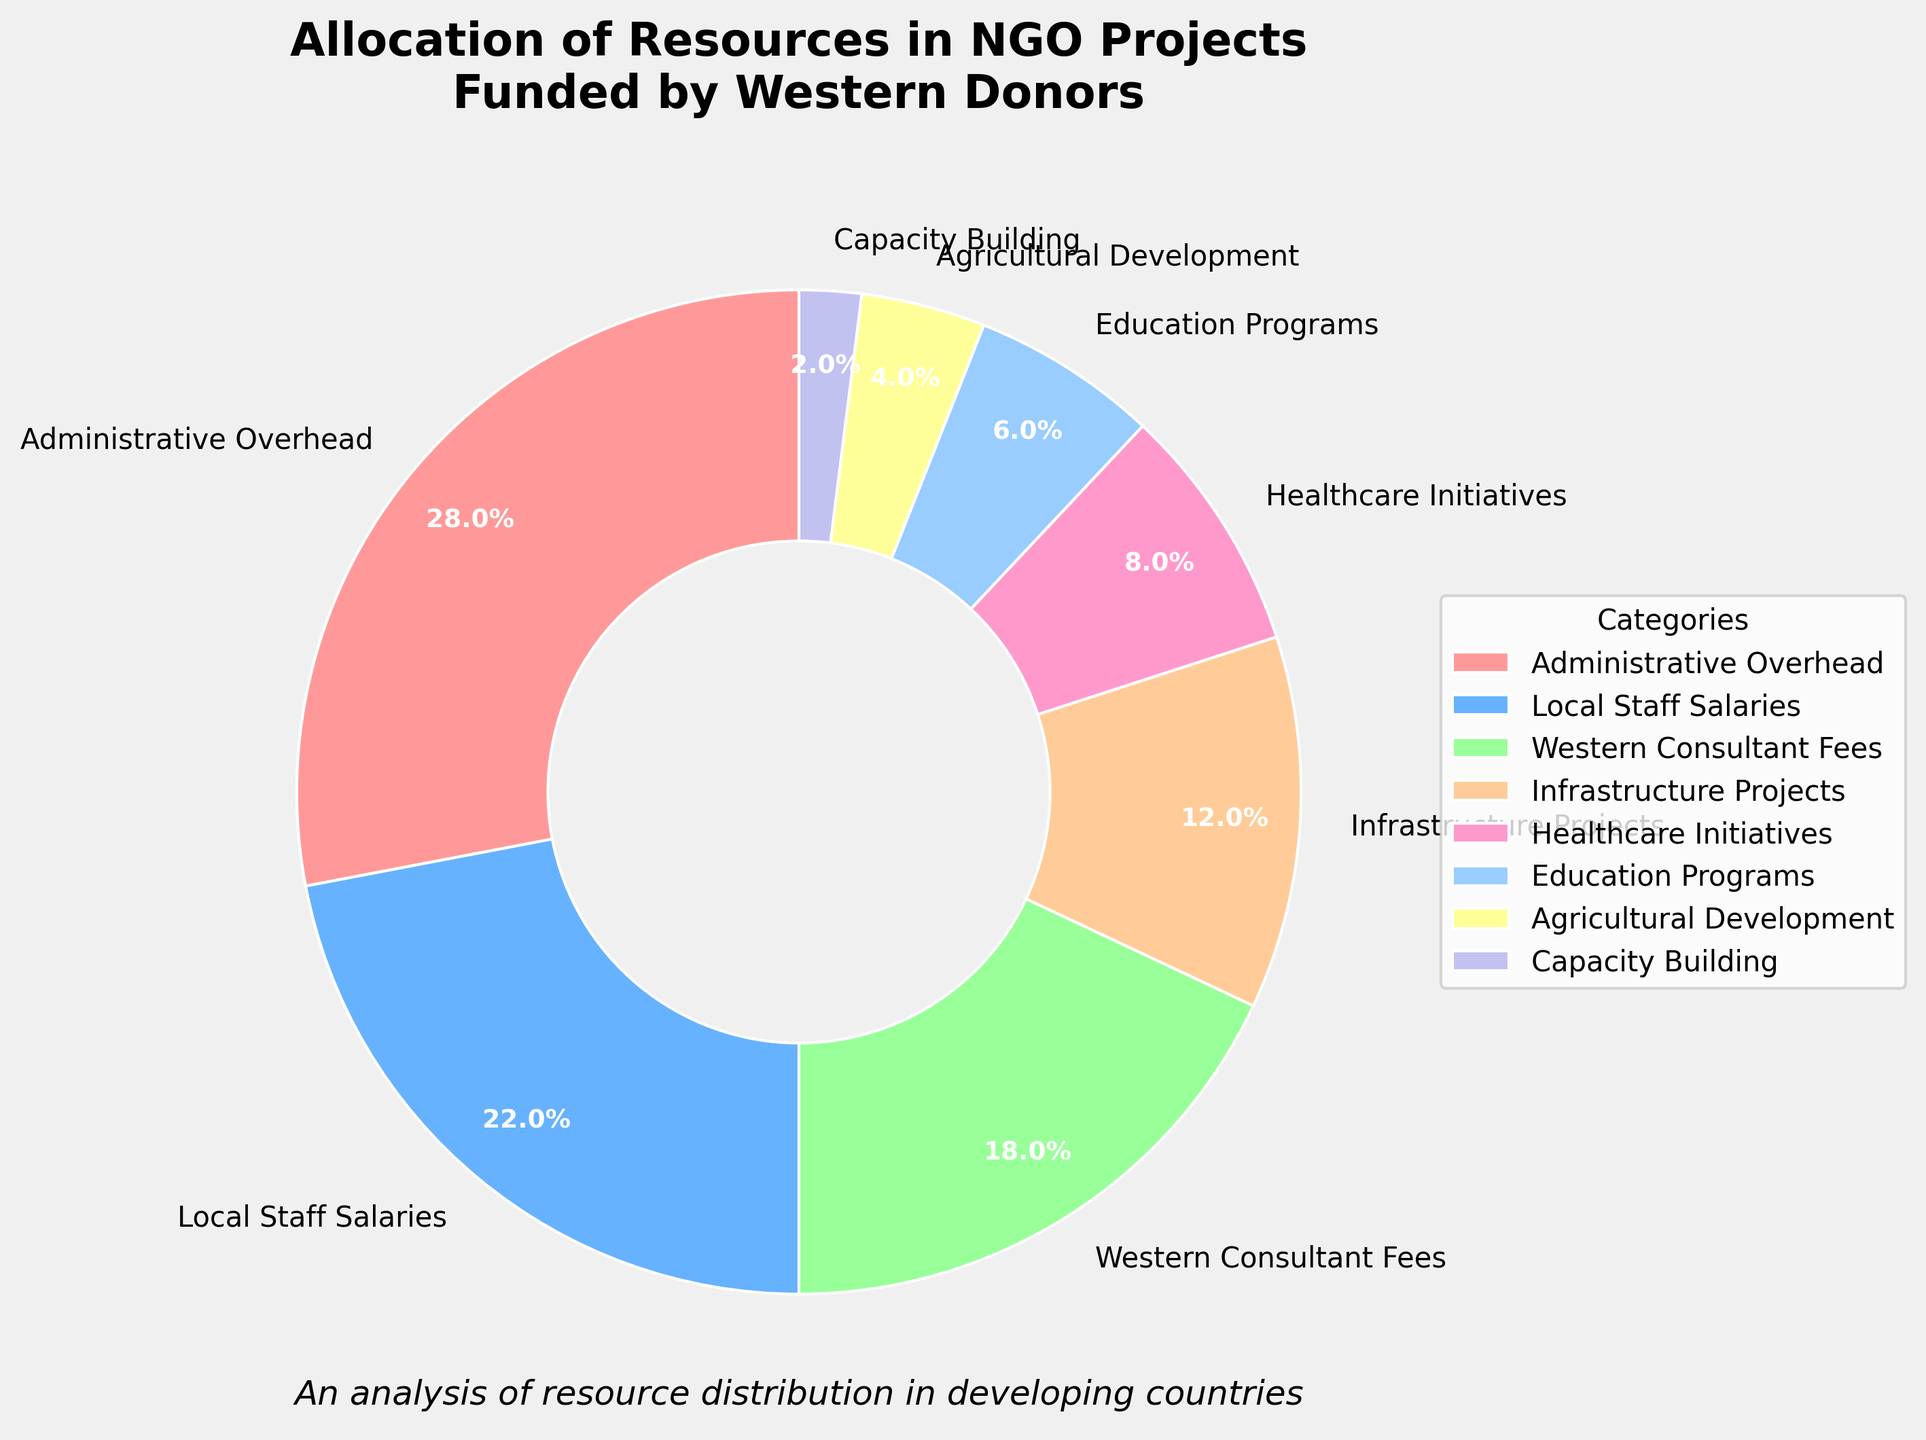What percentage of the resources is allocated to Agricultural Development? Locate the segment labeled "Agricultural Development" in the pie chart and read the corresponding percentage value.
Answer: 4% Sum the percentages of Local Staff Salaries and Western Consultant Fees. Identify the segments labeled "Local Staff Salaries" and "Western Consultant Fees" in the pie chart, add their percentages (22% + 18%).
Answer: 40% Which category receives fewer resources: Infrastructure Projects or Healthcare Initiatives? Compare the percentages of the segments labeled "Infrastructure Projects" (12%) and "Healthcare Initiatives" (8%) in the pie chart.
Answer: Healthcare Initiatives What is the color of the segment representing Education Programs? Locate the segment labeled "Education Programs" in the pie chart and observe its color.
Answer: Light Blue Calculate the difference in percentage between Administrative Overhead and Local Staff Salaries. Subtract the percentage of Local Staff Salaries (22%) from the percentage of Administrative Overhead (28%) by finding the respective segments in the pie chart.
Answer: 6% If the total funding is $100,000, how much is allocated to Infrastructure Projects in dollar amount? Convert the percentage of Infrastructure Projects (12%) to a dollar amount by taking 12% of $100,000, which is (12/100) * $100,000.
Answer: $12,000 Which category has the smallest allocation of resources? Identify the segment with the smallest percentage value in the pie chart.
Answer: Capacity Building What is the total percentage allocated to Education Programs, Healthcare Initiatives, and Agricultural Development combined? Locate the segments for Education Programs (6%), Healthcare Initiatives (8%), and Agricultural Development (4%) in the pie chart, then add their percentages (6% + 8% + 4%).
Answer: 18% Which two categories have a combined allocation closest to 50%? Compare the sums of percentages for different pairs of categories, looking for the pair that adds closest to 50%. Administrative Overhead (28%) and Local Staff Salaries (22%) result in 28% + 22%.
Answer: Administrative Overhead and Local Staff Salaries 